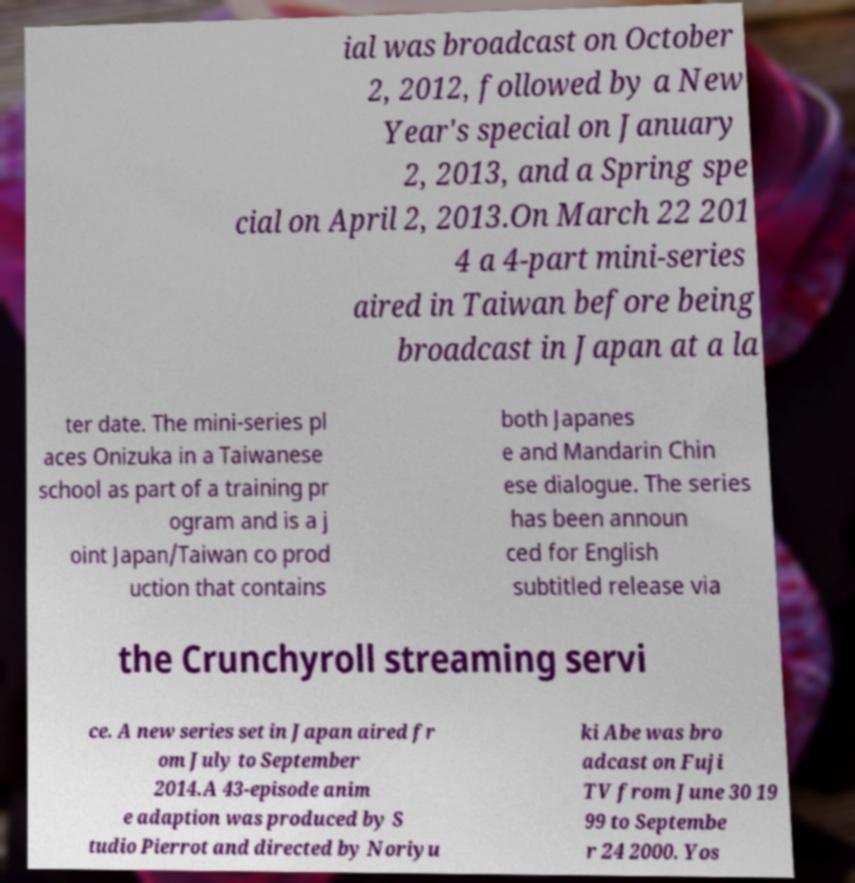Could you assist in decoding the text presented in this image and type it out clearly? ial was broadcast on October 2, 2012, followed by a New Year's special on January 2, 2013, and a Spring spe cial on April 2, 2013.On March 22 201 4 a 4-part mini-series aired in Taiwan before being broadcast in Japan at a la ter date. The mini-series pl aces Onizuka in a Taiwanese school as part of a training pr ogram and is a j oint Japan/Taiwan co prod uction that contains both Japanes e and Mandarin Chin ese dialogue. The series has been announ ced for English subtitled release via the Crunchyroll streaming servi ce. A new series set in Japan aired fr om July to September 2014.A 43-episode anim e adaption was produced by S tudio Pierrot and directed by Noriyu ki Abe was bro adcast on Fuji TV from June 30 19 99 to Septembe r 24 2000. Yos 